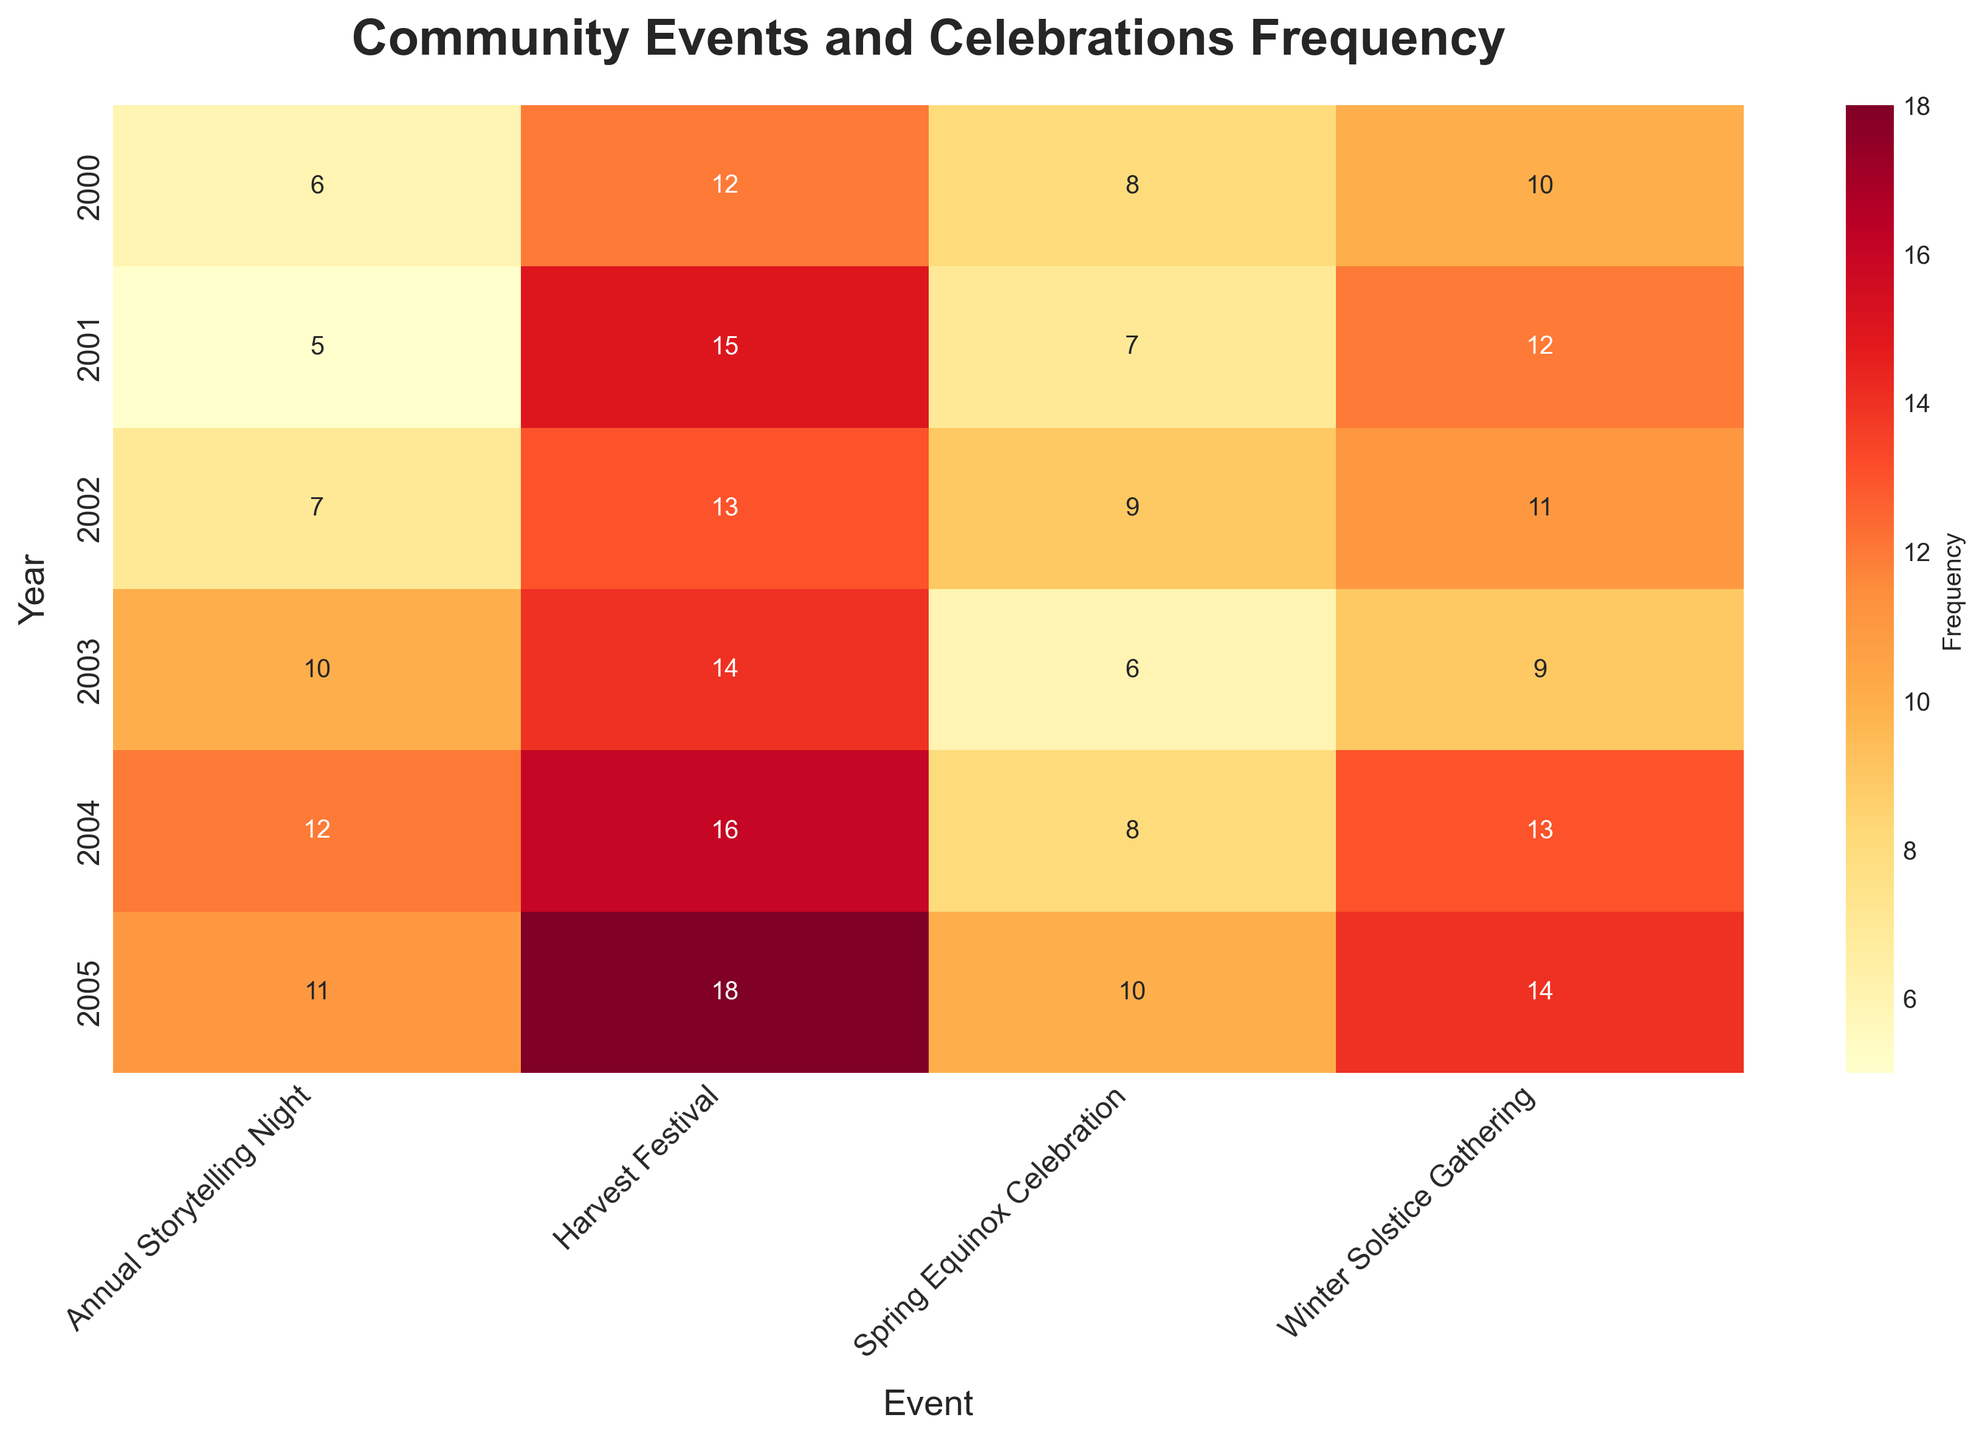What's the title of the heatmap? The title of a plot is typically located at the top of the figure. In this case, it says "Community Events and Celebrations Frequency".
Answer: Community Events and Celebrations Frequency Which year has the highest frequency for the Harvest Festival? The highest frequency for the Harvest Festival is found by locating the maximum value in the corresponding row labeled "Harvest Festival". The highest frequency is 18 in the year 2005.
Answer: 2005 How many times did the Winter Solstice Gathering occur in 2003? Look at the intersection between the "2003" row and the "Winter Solstice Gathering" column. The value is 9, indicating it occurred 9 times.
Answer: 9 What is the average frequency of the Annual Storytelling Night across all years? To find the average, sum the frequencies of the Annual Storytelling Night (6, 5, 7, 10, 12, 11) and then divide by the number of years (6). The sum is 51, so the average is 51 divided by 6, which is 8.5.
Answer: 8.5 Which event had a decrease in frequency from 2002 to 2003? Compare the frequencies of each event between 2002 and 2003. The Spring Equinox Celebration dropped from 9 to 6, and the Winter Solstice Gathering decreased from 11 to 9.
Answer: Spring Equinox Celebration, Winter Solstice Gathering Which event had the most consistent frequency over the years? To find the most consistent frequency, look for the event with the smallest variance over the years. By visually inspecting the heatmap, the Spring Equinox Celebration seems to have the least change in frequency values.
Answer: Spring Equinox Celebration What was the total frequency of all events in 2004? Sum the frequencies of all events in 2004: Harvest Festival (16), Spring Equinox Celebration (8), Winter Solstice Gathering (13), Annual Storytelling Night (12). The sum is 16 + 8 + 13 + 12 = 49.
Answer: 49 In which year was the frequency of the Spring Equinox Celebration the highest? Look for the maximum value in the Spring Equinox Celebration column. The highest frequency is 10 in the year 2005.
Answer: 2005 Which event showed an increase in frequency every year from 2000 to 2004? Review each event's frequency data over the years. The Harvest Festival shows a continuous increase from 2000 (12) to 2004 (16).
Answer: Harvest Festival 